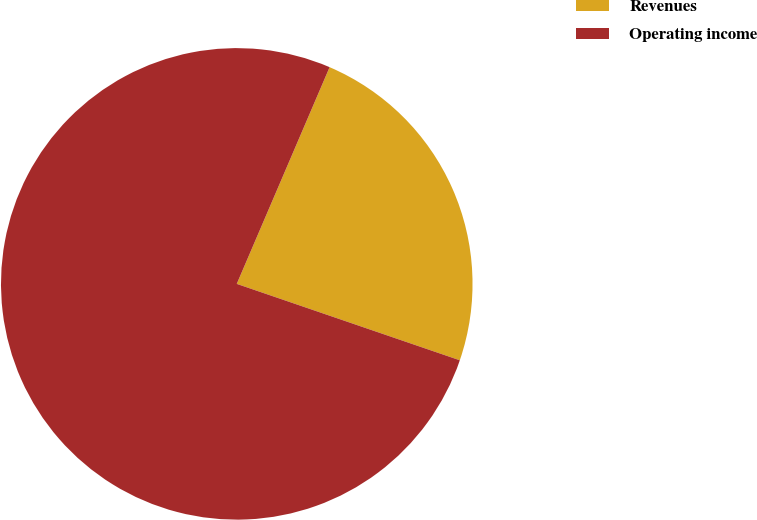Convert chart. <chart><loc_0><loc_0><loc_500><loc_500><pie_chart><fcel>Revenues<fcel>Operating income<nl><fcel>23.81%<fcel>76.19%<nl></chart> 